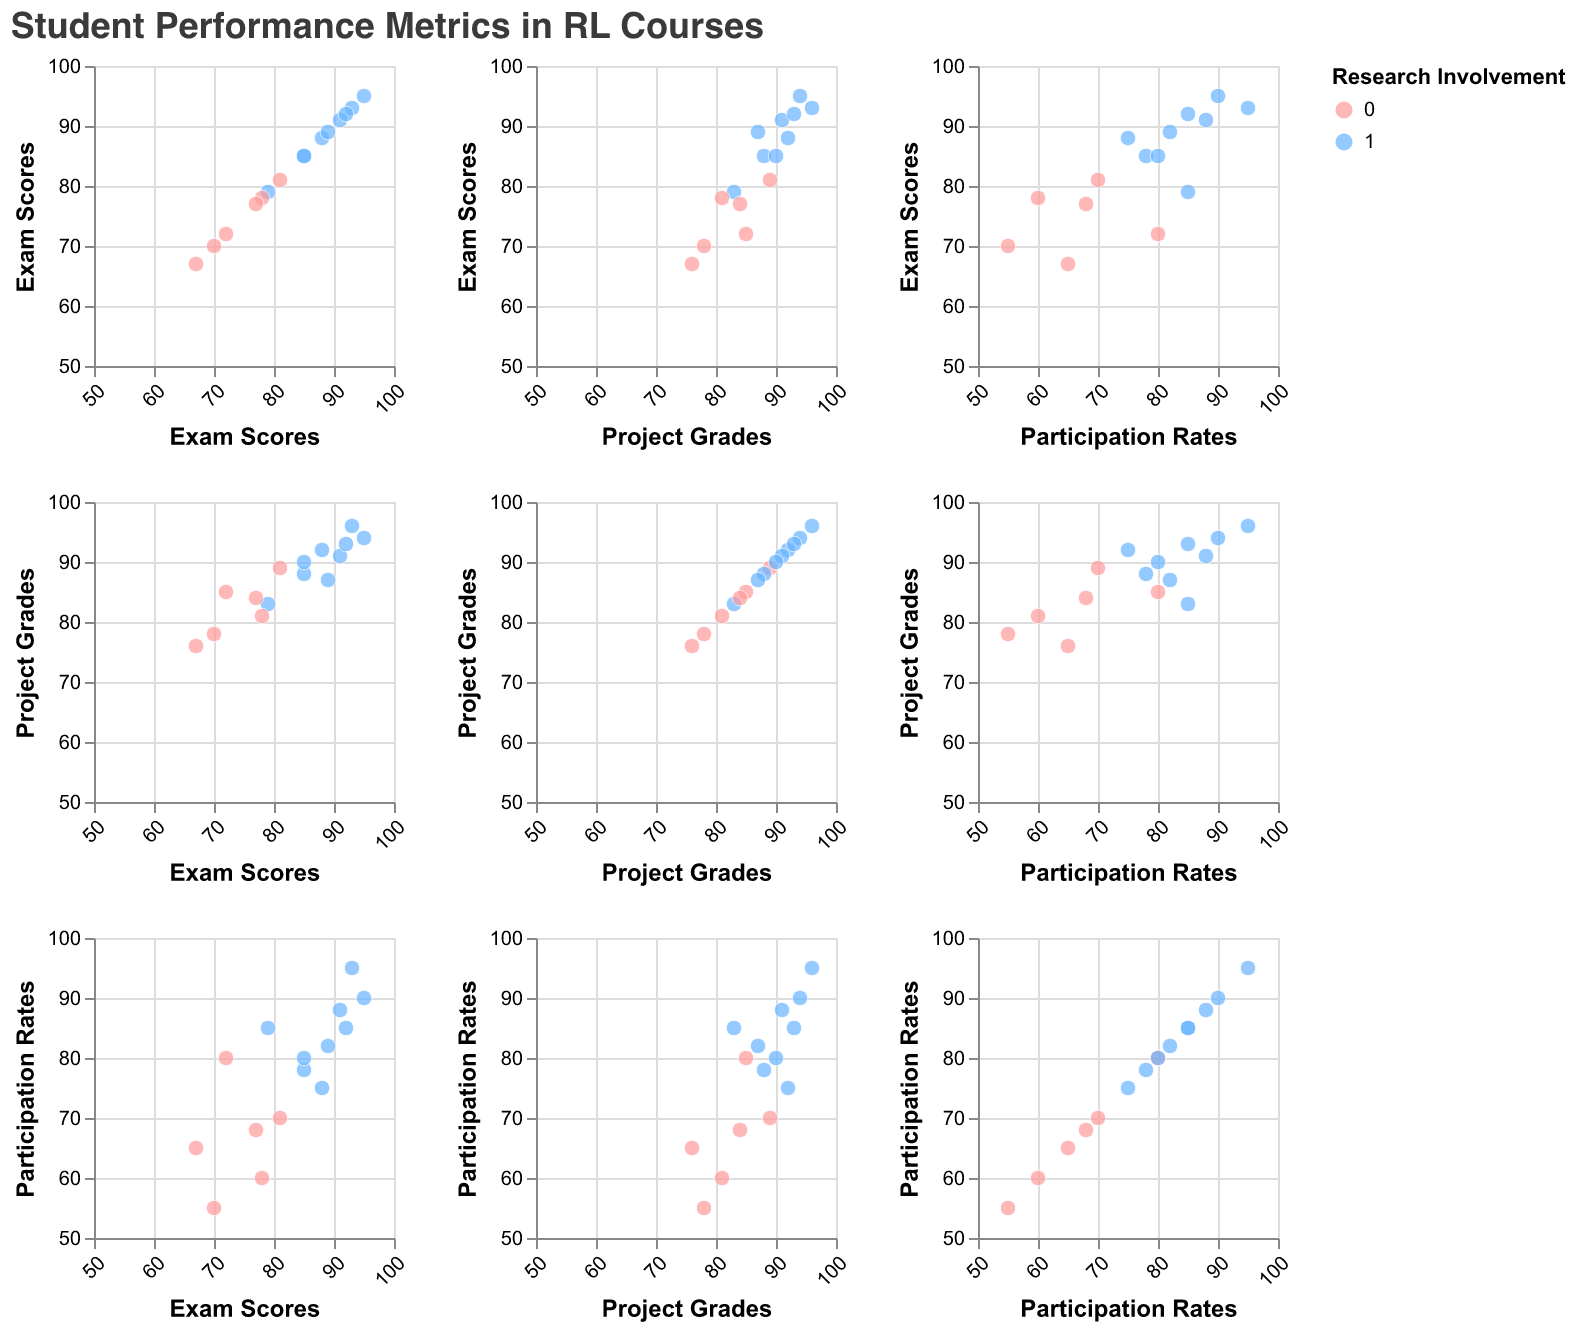What is the title of the scatter plot matrix? The title of the SPLOM is usually placed at the top of the figure. By reading the top of this plot, we find that the title is "Student Performance Metrics in RL Courses".
Answer: Student Performance Metrics in RL Courses What is the color representation in the scatter plot matrix? The color of the data points in the SPLOM represents "Post-course Research Involvement". The legend on the right indicates that students involved in post-course research are marked in blue, whereas those not involved are marked in pink.
Answer: Post-course Research Involvement On the SPLOM, which metric pairs exhibit a clustered pattern? By examining the scatter plots, it's evident that some metric pairs, notably "Exam Scores" vs. "Project Grades" and "Project Grades" vs. "Participation Rates", display a clustered pattern suggesting positive correlations. Points in these plots tend to form a diagonal cluster from the bottom-left to the top-right.
Answer: Exam Scores vs. Project Grades and Project Grades vs. Participation Rates Do higher exam scores correlate with higher project grades? One can determine correlations by looking for a diagonal pattern in the subplot where "Exam Scores" is plotted against "Project Grades". In this SPLOM, such a pattern is observed, indicating a positive correlation between higher exam scores and project grades.
Answer: Yes Which student had the highest exam score? The highest point on the "Exam Scores" axis in any subplot indicates the student with the highest exam score. In this plot, "Catherine Lee" marked at 95 has the highest score.
Answer: Catherine Lee Is there a noticeable participation rate difference between students involved in post-course research and those who aren't? By comparing the colored clusters of participation rates, it’s evident that students involved in post-course research (blue points) generally have higher participation rates compared to those who aren’t (pink points).
Answer: Yes Which pair of students have matching project grades but different research involvement status? By looking for points in the "Project Grades" axis that align vertically or horizontally in the subplots and checking their color difference, we find "Alice Johnson" and "Bob Smith", who both have project grades of 92 and 85 respectively, but different research involvement status.
Answer: Alice Johnson and Bob Smith How many students scored above 90 in both exam scores and project grades? By examining data points that fall above 90 in the scatter plot where "Exam Scores" are plotted against "Project Grades", we count a total of 6 students (Catherine Lee, Grace Kim, Isabella Davis, Olivia Robinson, Alice Johnson, Karen White).
Answer: 6 students What trend can be observed between participation rates and post-course research involvement? Observing the data points' colors in the subplots involving "Participation Rates", it is clear that students involved in post-course research (blue points) tend to have higher participation rates compared to those not involved (pink points).
Answer: Higher participation rates correlate with involvement in post-course research 